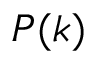Convert formula to latex. <formula><loc_0><loc_0><loc_500><loc_500>P ( k )</formula> 